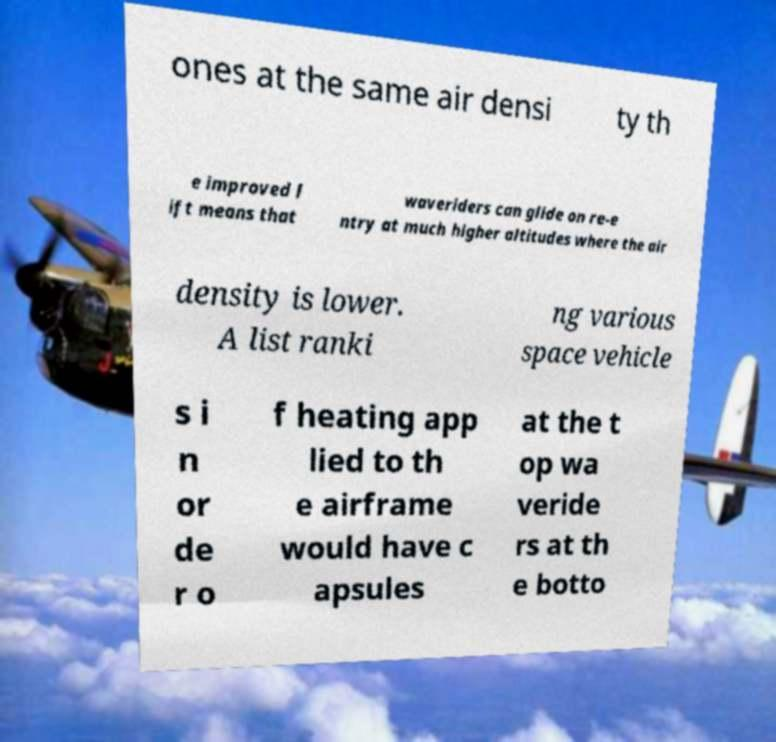Could you extract and type out the text from this image? ones at the same air densi ty th e improved l ift means that waveriders can glide on re-e ntry at much higher altitudes where the air density is lower. A list ranki ng various space vehicle s i n or de r o f heating app lied to th e airframe would have c apsules at the t op wa veride rs at th e botto 